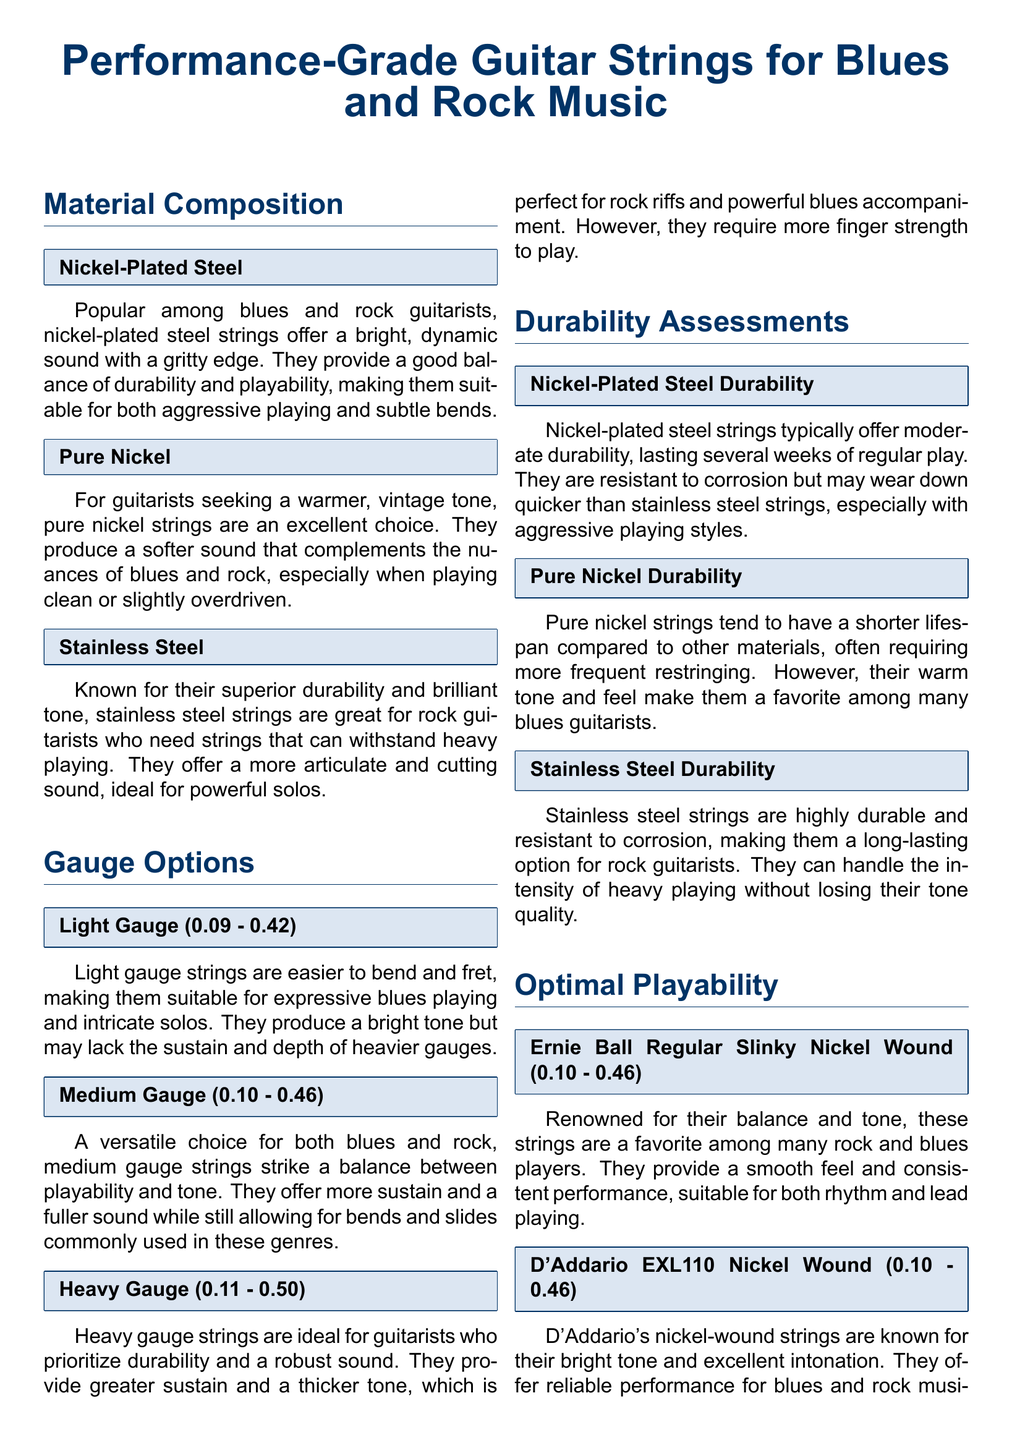What material is commonly used for blues and rock guitar strings? The material composition section highlights nickel-plated steel as a popular choice among blues and rock guitarists.
Answer: Nickel-Plated Steel What gauge is considered light? The gauge options section specifies that light gauge strings range from 0.09 to 0.42.
Answer: 0.09 - 0.42 Which type of strings offers a warmer tone? Pure nickel strings are stated as providing a warmer, vintage tone in the material composition section.
Answer: Pure Nickel What is the durability assessment for stainless steel strings? The document notes that stainless steel strings are highly durable and resistant to corrosion.
Answer: Highly durable Which specific product is renowned for balance and tone? The optimal playability section mentions the Ernie Ball Regular Slinky Nickel Wound strings as renowned for their balance and tone.
Answer: Ernie Ball Regular Slinky Nickel Wound In terms of gauge, which strings can handle powerful solos better? Heavy gauge strings, as indicated in the gauge options section, are ideal for guitarists who prioritize durability and a robust sound.
Answer: Heavy Gauge How often do pure nickel strings require restringing? The durability assessment section mentions that pure nickel strings tend to have a shorter lifespan, often requiring more frequent restringing.
Answer: More frequent restringing What do light gauge strings lack compared to heavier gauges? The gauge options section states that light gauge strings may lack the sustain and depth of heavier gauges.
Answer: Sustain and depth Which strings are favored for their ability to withstand heavy playing? Stainless steel strings, as stated in the durability assessments, are great for rock guitarists needing strings that can withstand heavy playing.
Answer: Stainless Steel 